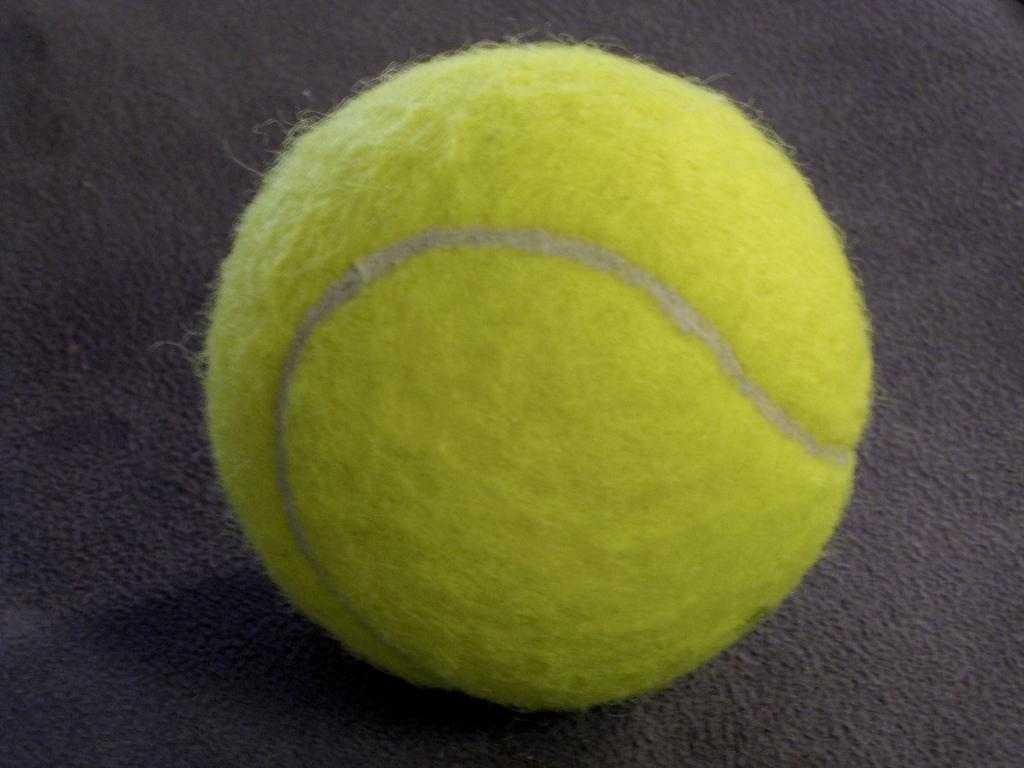What object is present on the carpet in the image? There is a ball on the carpet in the image. What type of rabbit can be seen hopping near the ball in the image? There is no rabbit present in the image; it only features a ball on a carpet. 